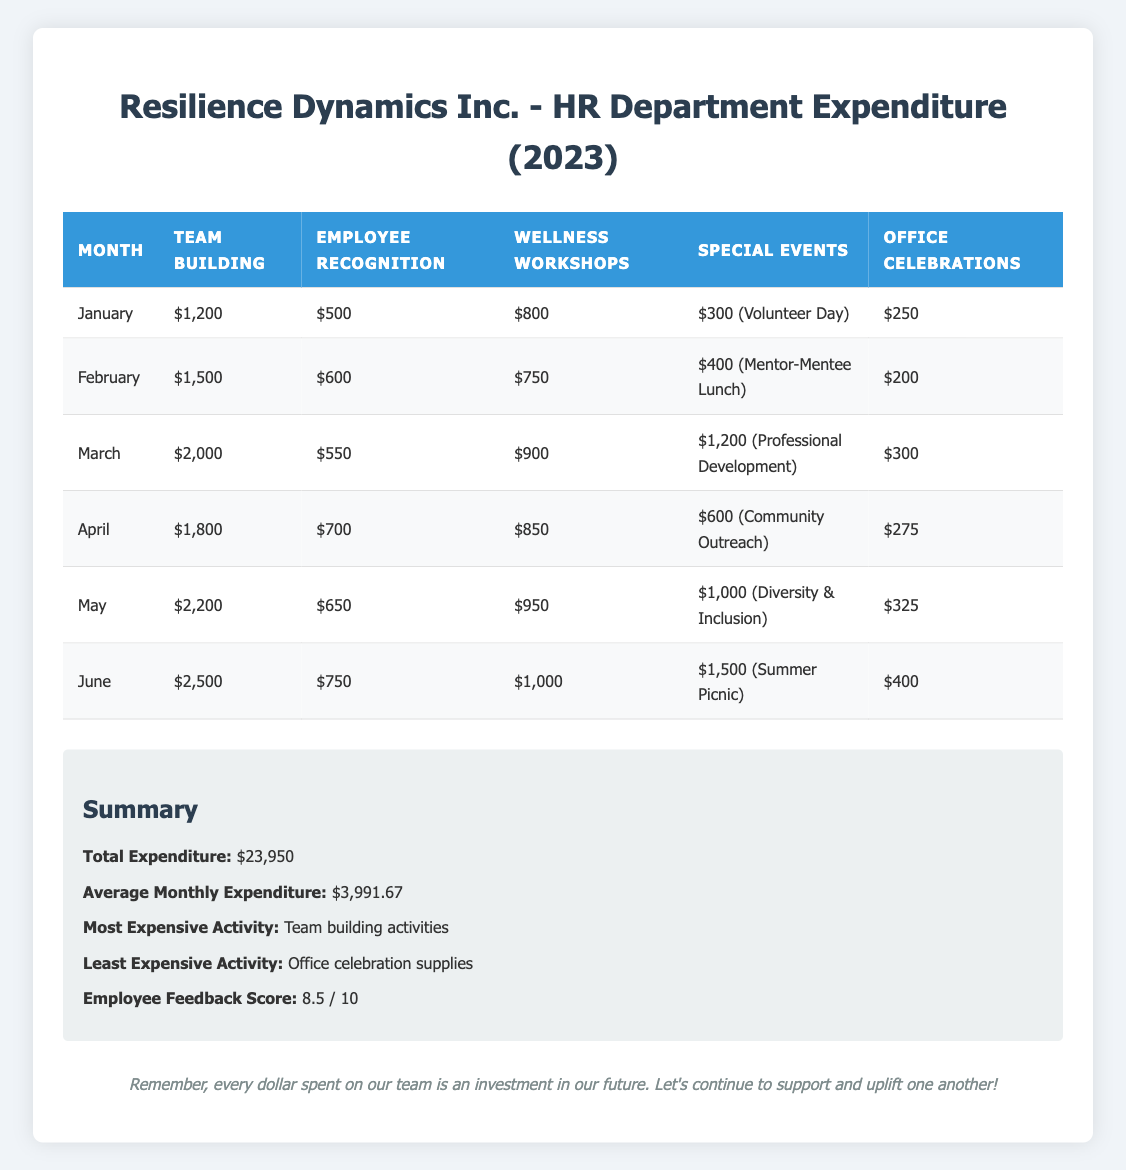What is the total expenditure for team-building activities in 2023? To find the total expenditure on team-building activities, we need to sum the amounts spent each month. The monthly expenditures are: January ($1,200), February ($1,500), March ($2,000), April ($1,800), May ($2,200), and June ($2,500). Adding these gives: 1,200 + 1,500 + 2,000 + 1,800 + 2,200 + 2,500 = $11,200.
Answer: $11,200 Which month had the highest expenditure on wellness workshops? The expenditures on wellness workshops by month are: January ($800), February ($750), March ($900), April ($850), May ($950), and June ($1,000). Comparing these values, June has the highest expenditure of $1,000.
Answer: June What is the average monthly expenditure across all initiatives? The average monthly expenditure is calculated by dividing the total expenditure ($23,950) by the number of months (6). Therefore, the average is 23,950/6 = $3,991.67.
Answer: $3,991.67 Did the company spend more on employee recognition programs or wellness workshops in May? In May, the expenditure on the employee recognition program is $650, while for wellness workshops, it is $950. Since $950 is greater than $650, the company spent more on wellness workshops in May.
Answer: Yes How much did the company spend on special events from January to June combined? The expenditures on special events each month are: January ($300), February ($400), March ($1,200), April ($600), May ($1,000), and June ($1,500). Summing these values gives: 300 + 400 + 1,200 + 600 + 1,000 + 1,500 = $4,000.
Answer: $4,000 Which month had the least expenditure on office celebration supplies? The amounts spent on office celebration supplies are as follows: January ($250), February ($200), March ($300), April ($275), May ($325), June ($400). February has the lowest amount spent at $200.
Answer: February What is the total expenditure on wellness workshops compared to team-building activities in the first half of 2023? The total expenditure on wellness workshops is calculated as follows: January ($800) + February ($750) + March ($900) + April ($850) + May ($950) + June ($1,000) = $4,250. The total expenditure on team-building activities is: 1,200 + 1,500 + 2,000 + 1,800 + 2,200 + 2,500 = $11,200. Comparing the two totals: $4,250 is less than $11,200.
Answer: Team-building activities are greater Is the employee feedback score higher than 8? The employee feedback score provided is 8.5, which is greater than 8.
Answer: Yes 